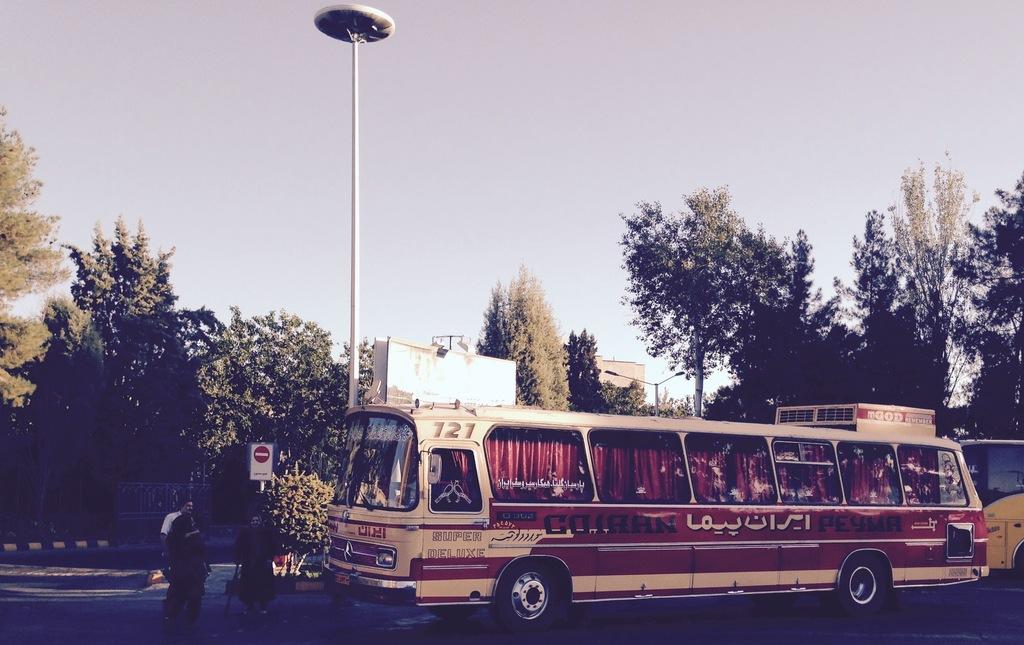What is the bus number?
Your answer should be compact. 121. What kind of bus does it say at the bottom?
Offer a terse response. Super deluxe. 